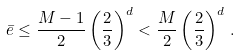<formula> <loc_0><loc_0><loc_500><loc_500>\bar { e } \leq \frac { M - 1 } { 2 } \left ( \frac { 2 } { 3 } \right ) ^ { d } < \frac { M } { 2 } \left ( \frac { 2 } { 3 } \right ) ^ { d } \, .</formula> 